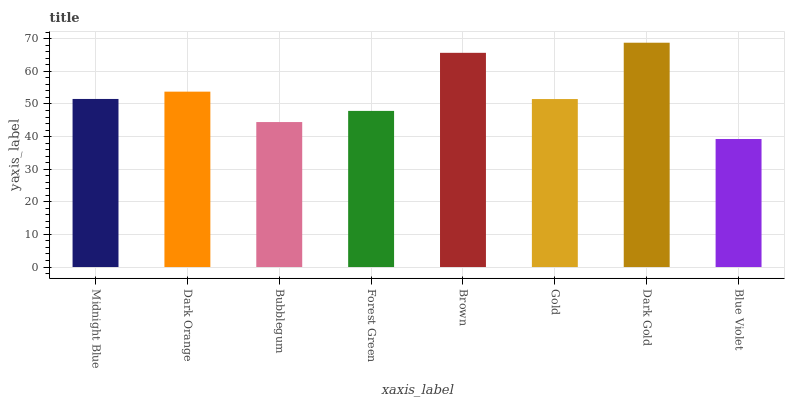Is Blue Violet the minimum?
Answer yes or no. Yes. Is Dark Gold the maximum?
Answer yes or no. Yes. Is Dark Orange the minimum?
Answer yes or no. No. Is Dark Orange the maximum?
Answer yes or no. No. Is Dark Orange greater than Midnight Blue?
Answer yes or no. Yes. Is Midnight Blue less than Dark Orange?
Answer yes or no. Yes. Is Midnight Blue greater than Dark Orange?
Answer yes or no. No. Is Dark Orange less than Midnight Blue?
Answer yes or no. No. Is Midnight Blue the high median?
Answer yes or no. Yes. Is Gold the low median?
Answer yes or no. Yes. Is Dark Orange the high median?
Answer yes or no. No. Is Brown the low median?
Answer yes or no. No. 